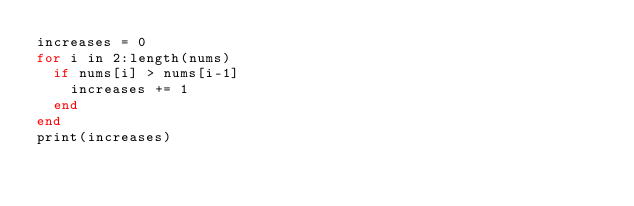<code> <loc_0><loc_0><loc_500><loc_500><_Julia_>increases = 0
for i in 2:length(nums)
  if nums[i] > nums[i-1]
    increases += 1
  end
end
print(increases)
</code> 